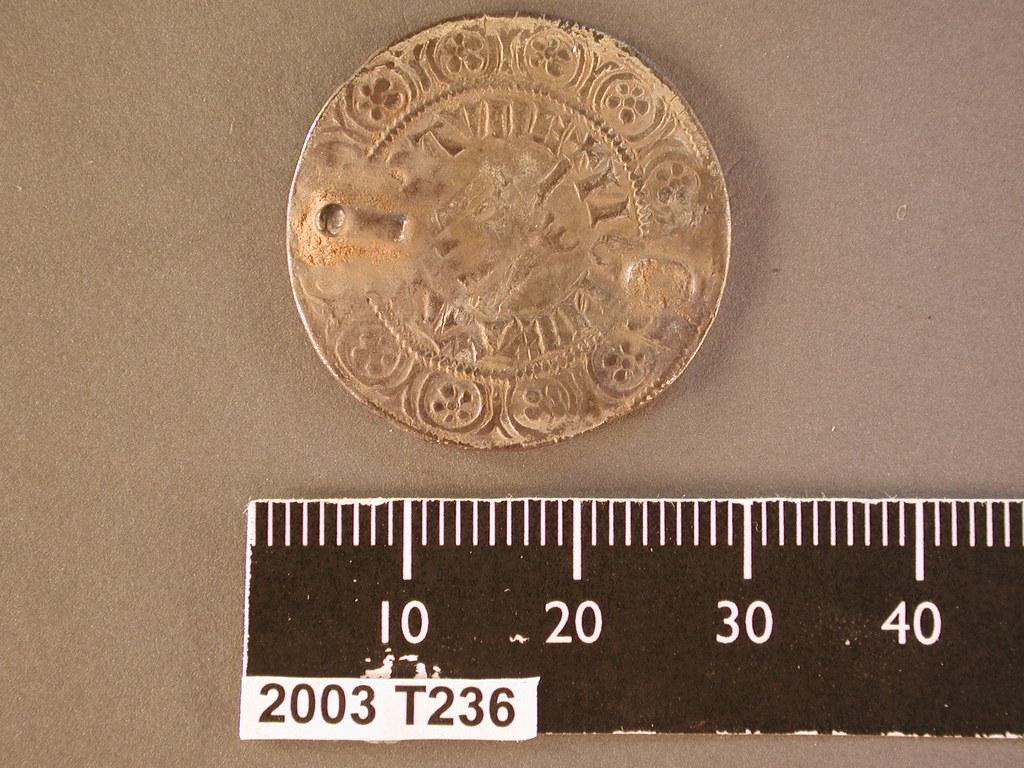<image>
Provide a brief description of the given image. A very old coin is measured and is about 30 millimetres in width. 